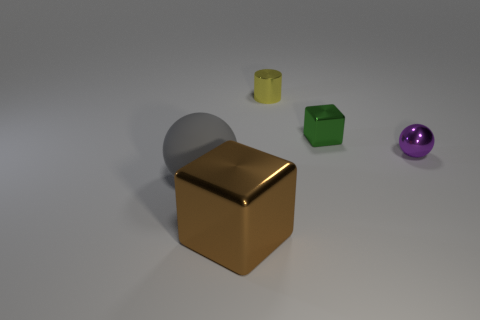There is a sphere right of the big object that is right of the big matte ball; what number of large rubber balls are on the right side of it? In the image, there is only one visible large rubber ball, which is purple in color and located to the left of the big glossy gold cube. Therefore, there are no large rubber balls on the right side of the sphere. 